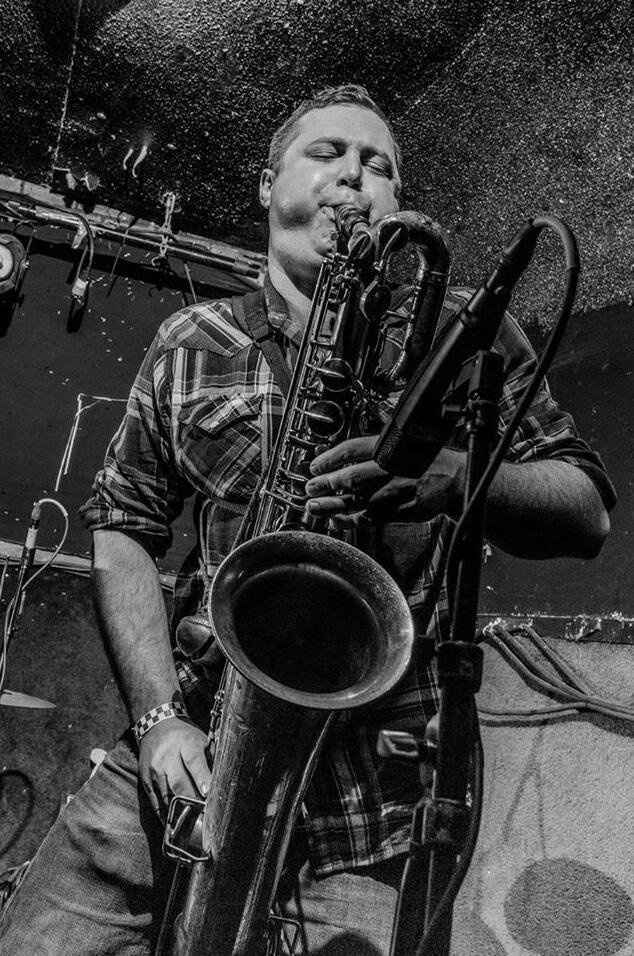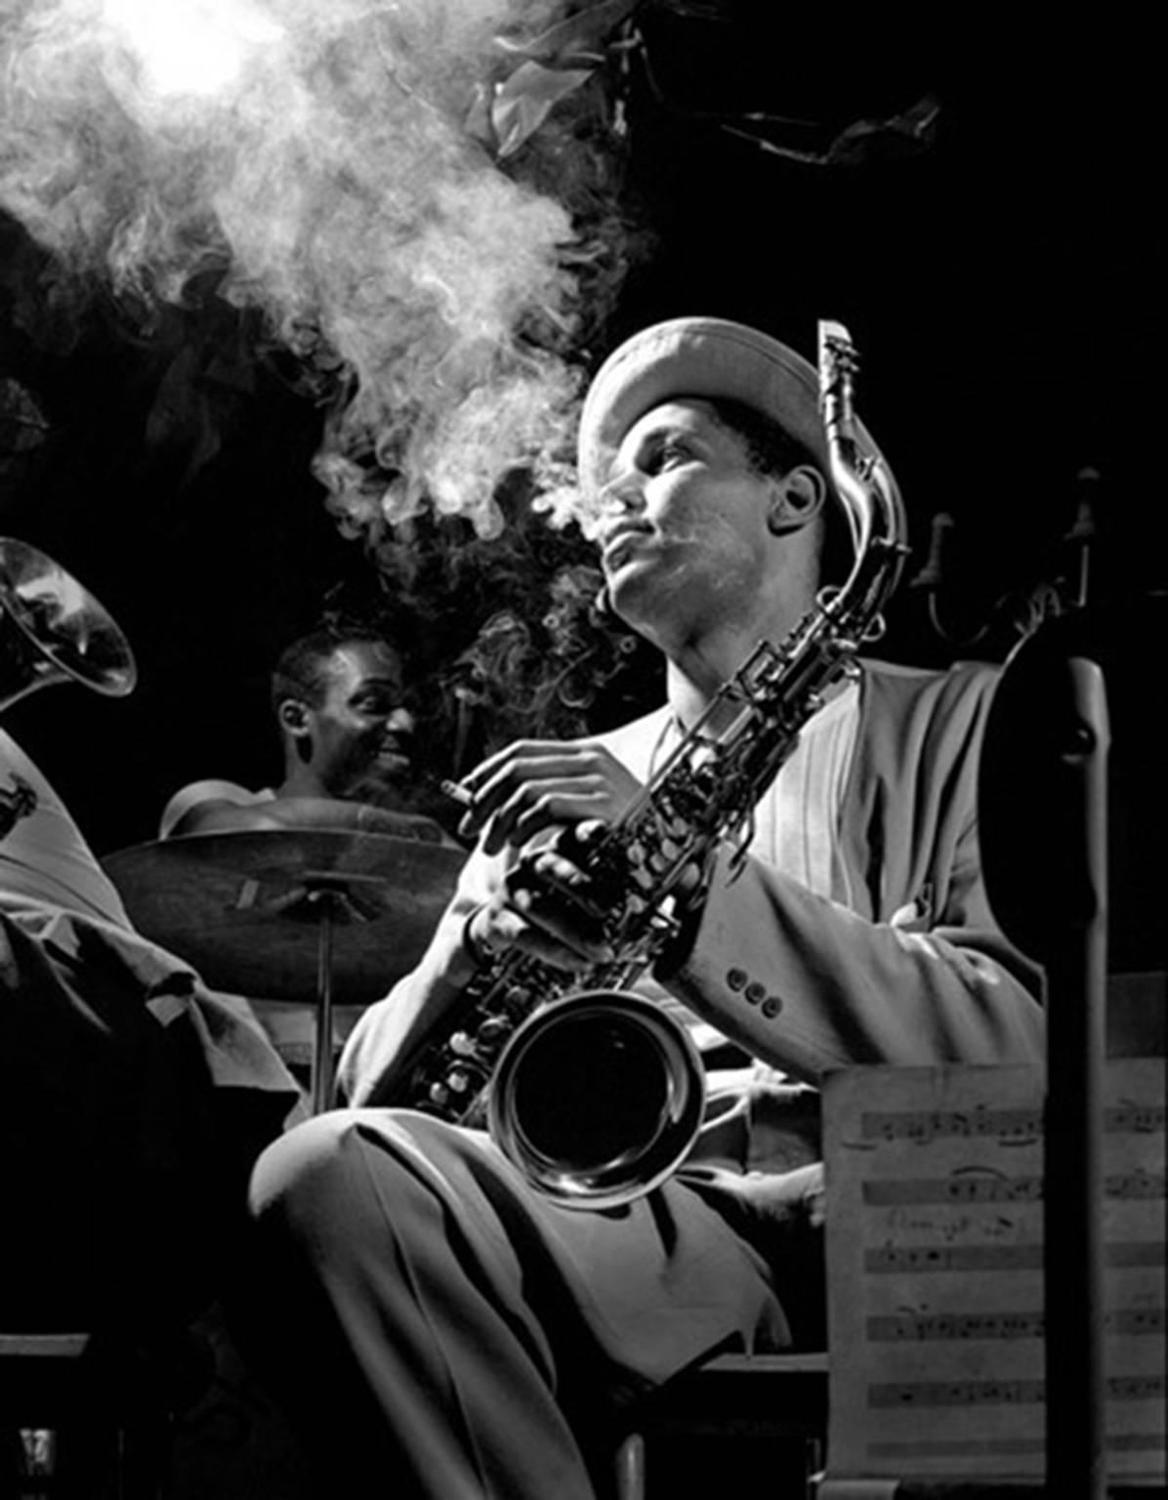The first image is the image on the left, the second image is the image on the right. Considering the images on both sides, is "An image shows a non-black man with bare forearms playing the sax." valid? Answer yes or no. Yes. The first image is the image on the left, the second image is the image on the right. For the images shown, is this caption "In one of the pictures a musician is wearing a hat." true? Answer yes or no. Yes. 